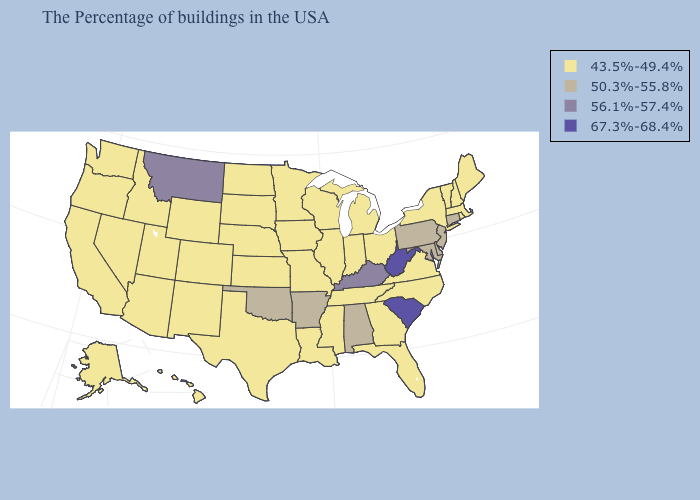Does Indiana have a higher value than Virginia?
Be succinct. No. What is the highest value in states that border California?
Give a very brief answer. 43.5%-49.4%. Name the states that have a value in the range 43.5%-49.4%?
Be succinct. Maine, Massachusetts, Rhode Island, New Hampshire, Vermont, New York, Virginia, North Carolina, Ohio, Florida, Georgia, Michigan, Indiana, Tennessee, Wisconsin, Illinois, Mississippi, Louisiana, Missouri, Minnesota, Iowa, Kansas, Nebraska, Texas, South Dakota, North Dakota, Wyoming, Colorado, New Mexico, Utah, Arizona, Idaho, Nevada, California, Washington, Oregon, Alaska, Hawaii. What is the value of Montana?
Short answer required. 56.1%-57.4%. What is the lowest value in the Northeast?
Short answer required. 43.5%-49.4%. Among the states that border South Dakota , does Montana have the highest value?
Give a very brief answer. Yes. Name the states that have a value in the range 43.5%-49.4%?
Short answer required. Maine, Massachusetts, Rhode Island, New Hampshire, Vermont, New York, Virginia, North Carolina, Ohio, Florida, Georgia, Michigan, Indiana, Tennessee, Wisconsin, Illinois, Mississippi, Louisiana, Missouri, Minnesota, Iowa, Kansas, Nebraska, Texas, South Dakota, North Dakota, Wyoming, Colorado, New Mexico, Utah, Arizona, Idaho, Nevada, California, Washington, Oregon, Alaska, Hawaii. Which states hav the highest value in the South?
Short answer required. South Carolina, West Virginia. Name the states that have a value in the range 56.1%-57.4%?
Write a very short answer. Kentucky, Montana. Does the first symbol in the legend represent the smallest category?
Quick response, please. Yes. Name the states that have a value in the range 50.3%-55.8%?
Keep it brief. Connecticut, New Jersey, Delaware, Maryland, Pennsylvania, Alabama, Arkansas, Oklahoma. What is the value of Wisconsin?
Write a very short answer. 43.5%-49.4%. What is the value of North Dakota?
Give a very brief answer. 43.5%-49.4%. Which states have the lowest value in the MidWest?
Quick response, please. Ohio, Michigan, Indiana, Wisconsin, Illinois, Missouri, Minnesota, Iowa, Kansas, Nebraska, South Dakota, North Dakota. Which states hav the highest value in the South?
Write a very short answer. South Carolina, West Virginia. 